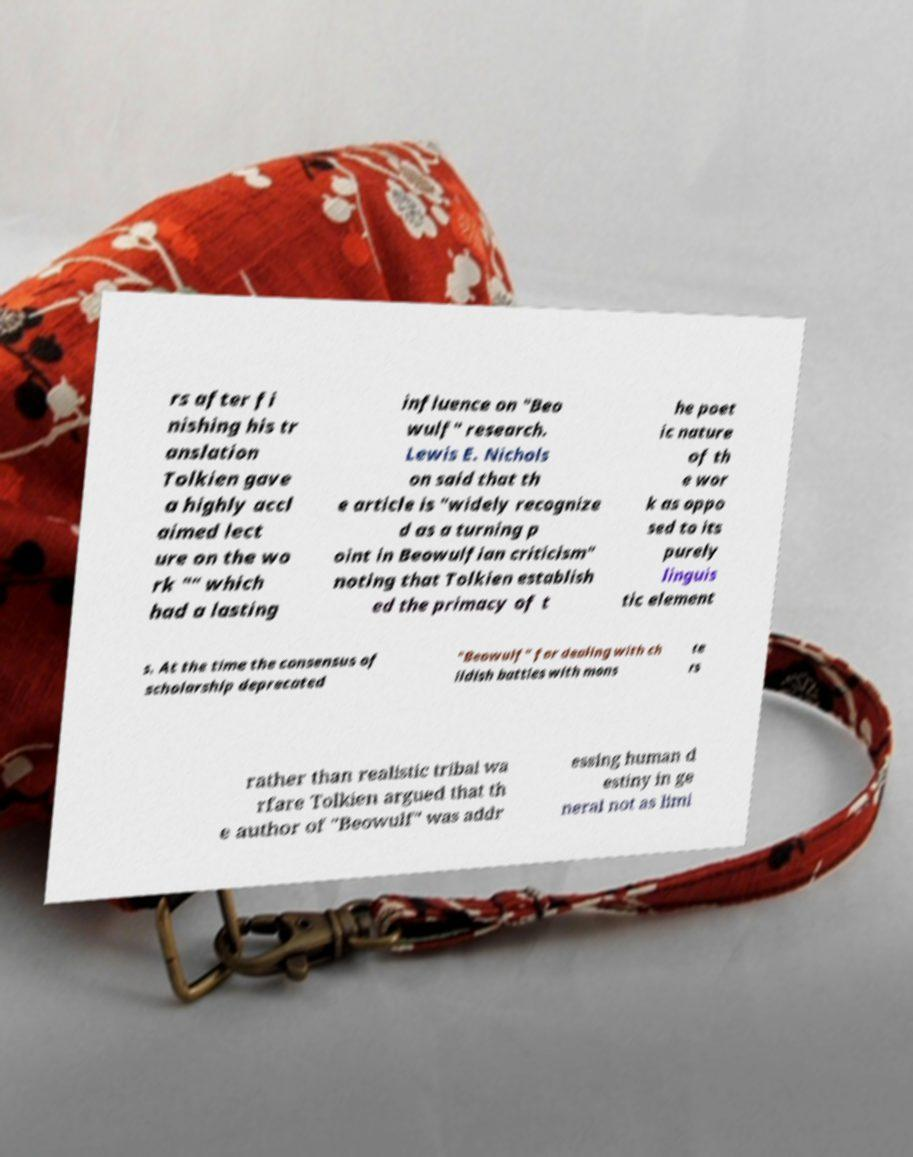Can you accurately transcribe the text from the provided image for me? rs after fi nishing his tr anslation Tolkien gave a highly accl aimed lect ure on the wo rk "" which had a lasting influence on "Beo wulf" research. Lewis E. Nichols on said that th e article is "widely recognize d as a turning p oint in Beowulfian criticism" noting that Tolkien establish ed the primacy of t he poet ic nature of th e wor k as oppo sed to its purely linguis tic element s. At the time the consensus of scholarship deprecated "Beowulf" for dealing with ch ildish battles with mons te rs rather than realistic tribal wa rfare Tolkien argued that th e author of "Beowulf" was addr essing human d estiny in ge neral not as limi 